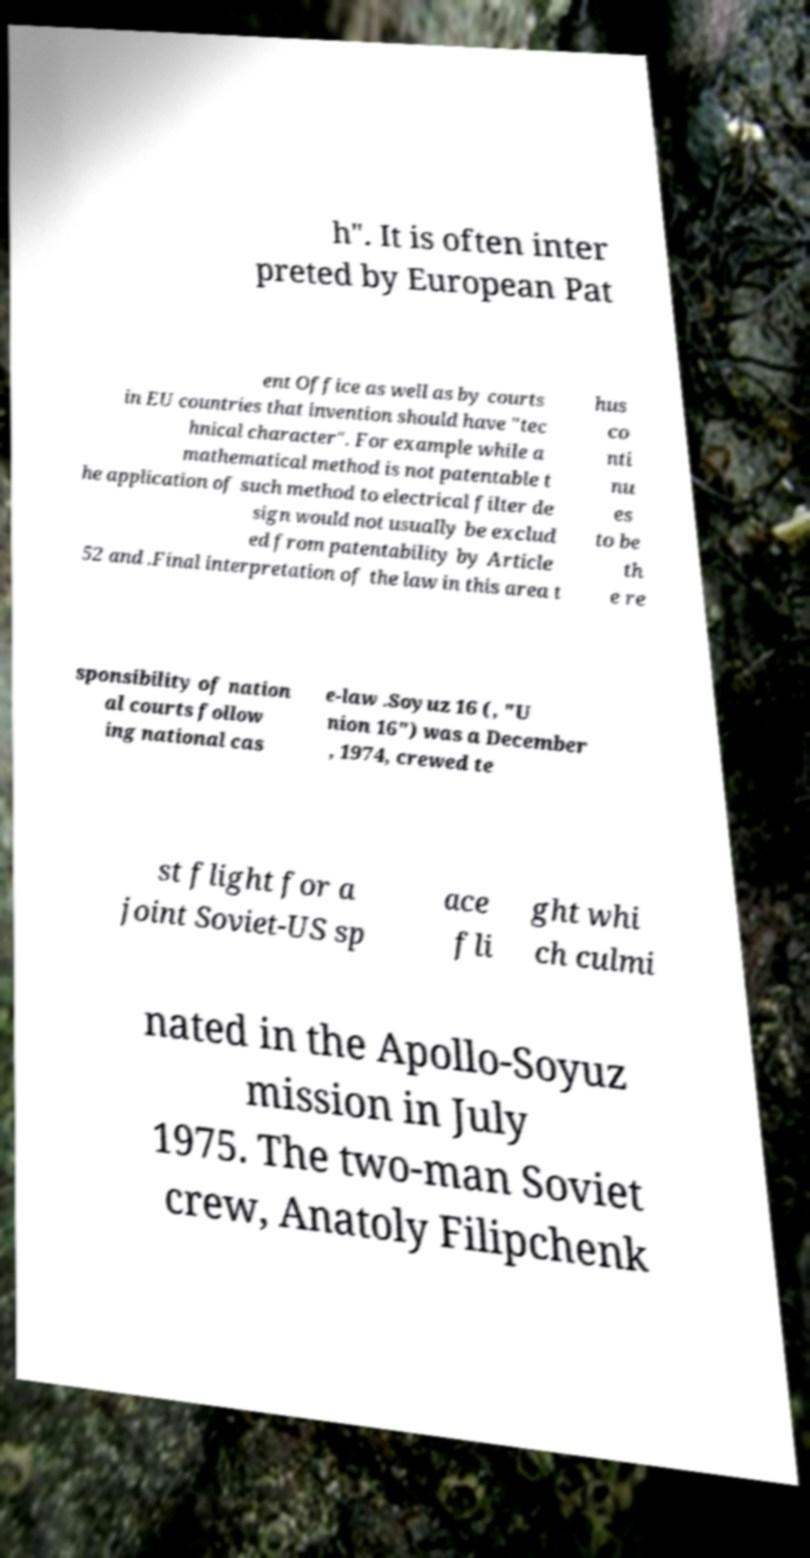Please identify and transcribe the text found in this image. h". It is often inter preted by European Pat ent Office as well as by courts in EU countries that invention should have "tec hnical character". For example while a mathematical method is not patentable t he application of such method to electrical filter de sign would not usually be exclud ed from patentability by Article 52 and .Final interpretation of the law in this area t hus co nti nu es to be th e re sponsibility of nation al courts follow ing national cas e-law .Soyuz 16 (, "U nion 16") was a December , 1974, crewed te st flight for a joint Soviet-US sp ace fli ght whi ch culmi nated in the Apollo-Soyuz mission in July 1975. The two-man Soviet crew, Anatoly Filipchenk 